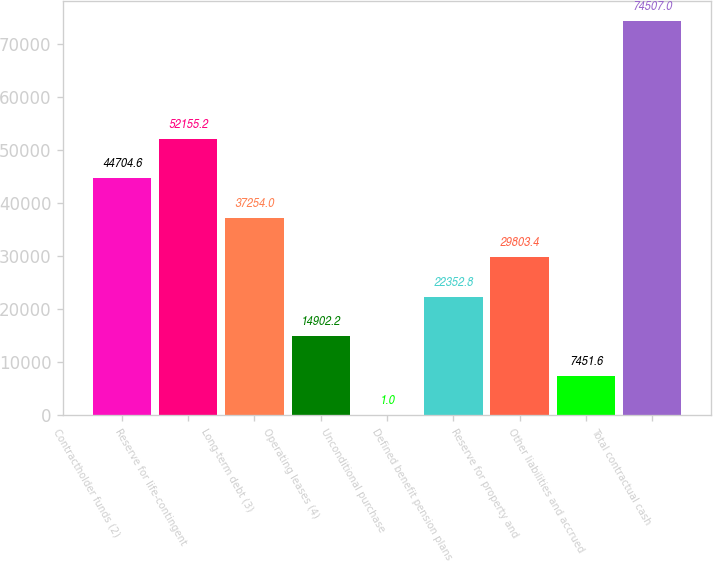Convert chart to OTSL. <chart><loc_0><loc_0><loc_500><loc_500><bar_chart><fcel>Contractholder funds (2)<fcel>Reserve for life-contingent<fcel>Long-term debt (3)<fcel>Operating leases (4)<fcel>Unconditional purchase<fcel>Defined benefit pension plans<fcel>Reserve for property and<fcel>Other liabilities and accrued<fcel>Total contractual cash<nl><fcel>44704.6<fcel>52155.2<fcel>37254<fcel>14902.2<fcel>1<fcel>22352.8<fcel>29803.4<fcel>7451.6<fcel>74507<nl></chart> 